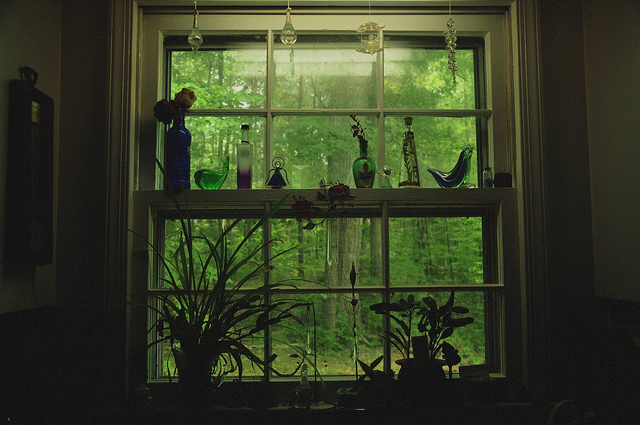<image>What movie is this from? I am not sure what movie this is from. What movie is this from? I don't know what movie this is from. It could be 'fences', 'room', 'leprechaun', 'secret garden' or 'real life'. 